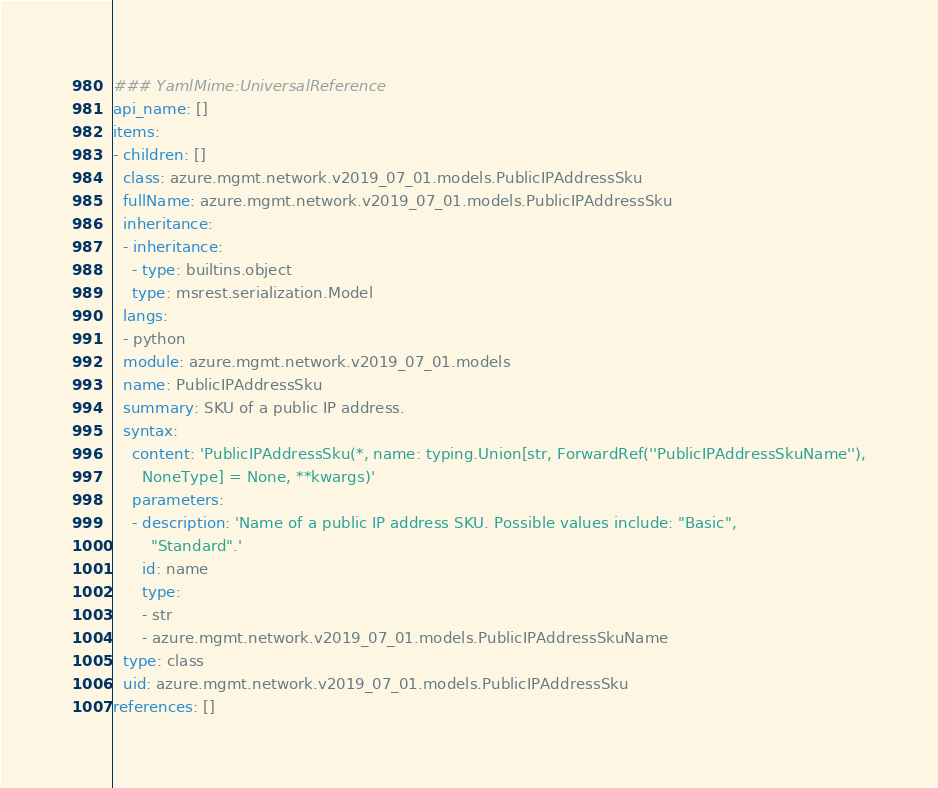Convert code to text. <code><loc_0><loc_0><loc_500><loc_500><_YAML_>### YamlMime:UniversalReference
api_name: []
items:
- children: []
  class: azure.mgmt.network.v2019_07_01.models.PublicIPAddressSku
  fullName: azure.mgmt.network.v2019_07_01.models.PublicIPAddressSku
  inheritance:
  - inheritance:
    - type: builtins.object
    type: msrest.serialization.Model
  langs:
  - python
  module: azure.mgmt.network.v2019_07_01.models
  name: PublicIPAddressSku
  summary: SKU of a public IP address.
  syntax:
    content: 'PublicIPAddressSku(*, name: typing.Union[str, ForwardRef(''PublicIPAddressSkuName''),
      NoneType] = None, **kwargs)'
    parameters:
    - description: 'Name of a public IP address SKU. Possible values include: "Basic",
        "Standard".'
      id: name
      type:
      - str
      - azure.mgmt.network.v2019_07_01.models.PublicIPAddressSkuName
  type: class
  uid: azure.mgmt.network.v2019_07_01.models.PublicIPAddressSku
references: []
</code> 